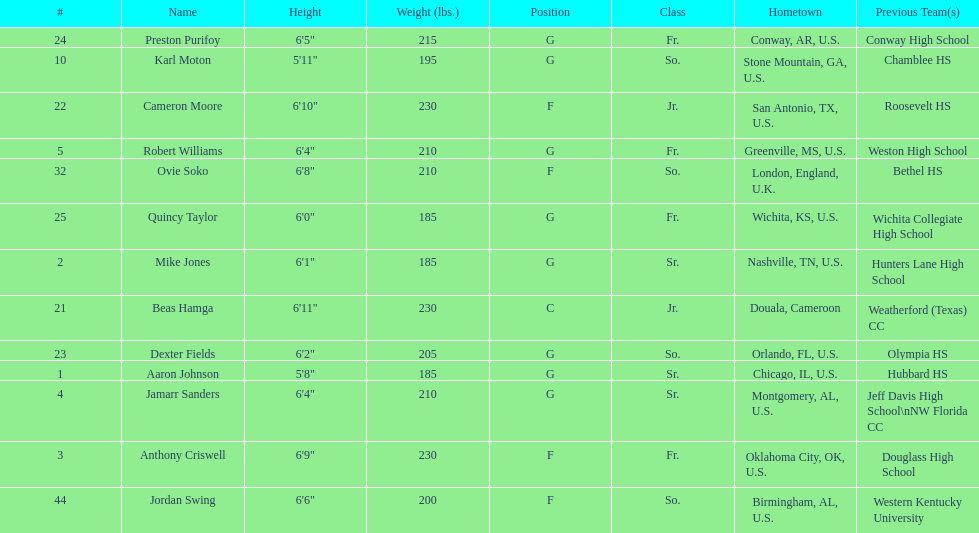What is the number of seniors on the team? 3. 